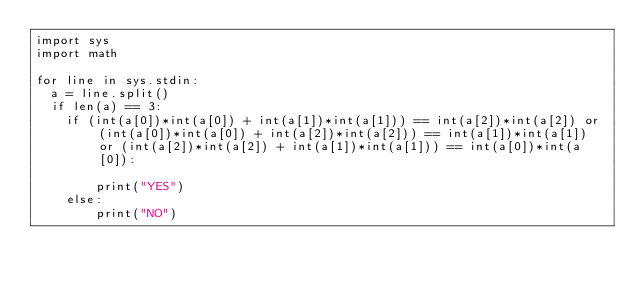Convert code to text. <code><loc_0><loc_0><loc_500><loc_500><_Python_>import sys
import math

for line in sys.stdin:
  a = line.split()
  if len(a) == 3:
    if (int(a[0])*int(a[0]) + int(a[1])*int(a[1])) == int(a[2])*int(a[2]) or (int(a[0])*int(a[0]) + int(a[2])*int(a[2])) == int(a[1])*int(a[1]) or (int(a[2])*int(a[2]) + int(a[1])*int(a[1])) == int(a[0])*int(a[0]):
    
        print("YES")
    else:
        print("NO")</code> 